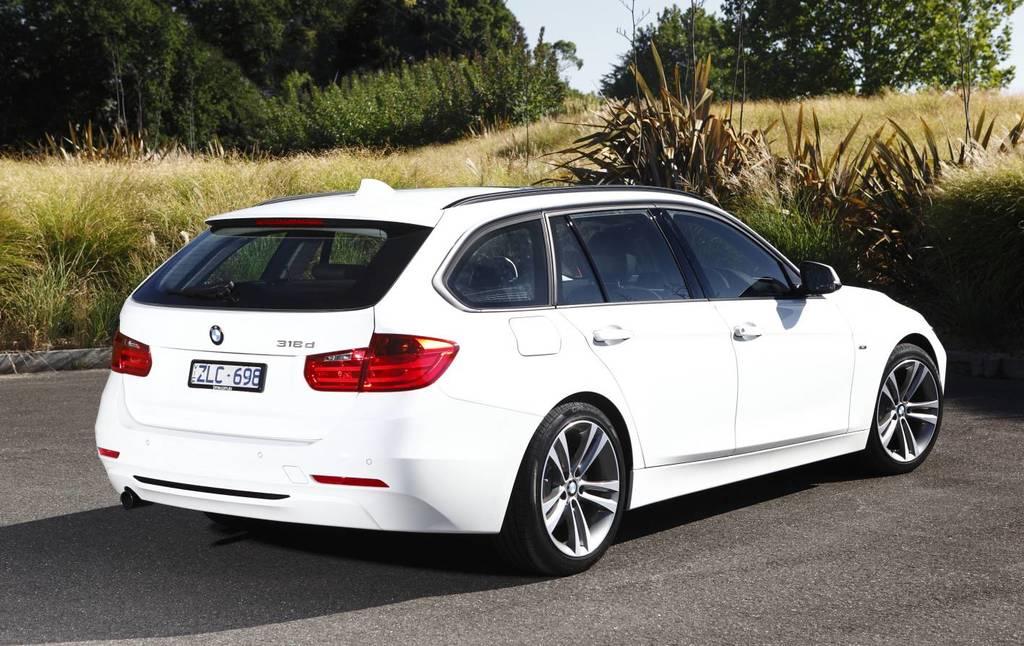What is the first number on the license plate?
Provide a succinct answer. 6. 